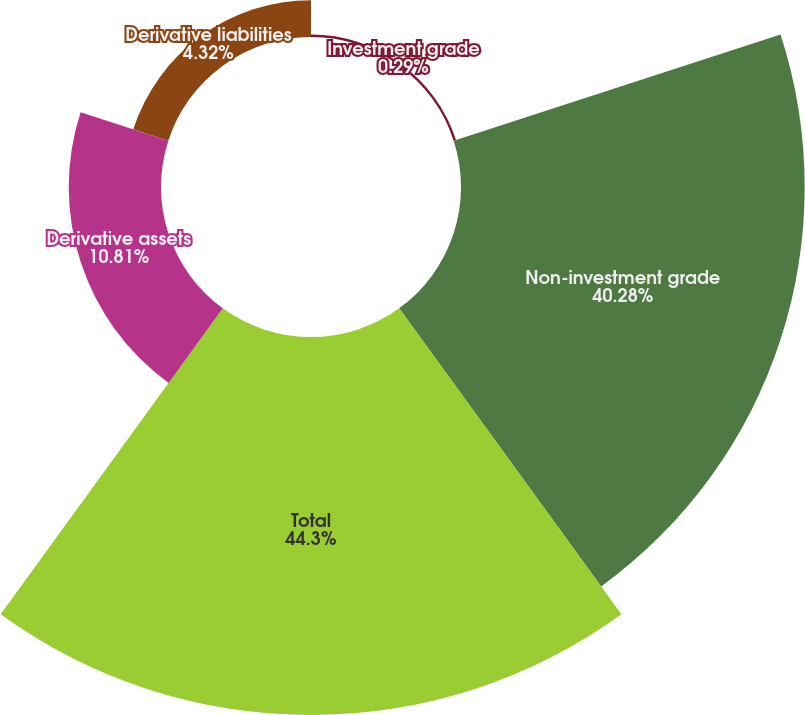Convert chart. <chart><loc_0><loc_0><loc_500><loc_500><pie_chart><fcel>Investment grade<fcel>Non-investment grade<fcel>Total<fcel>Derivative assets<fcel>Derivative liabilities<nl><fcel>0.29%<fcel>40.28%<fcel>44.3%<fcel>10.81%<fcel>4.32%<nl></chart> 